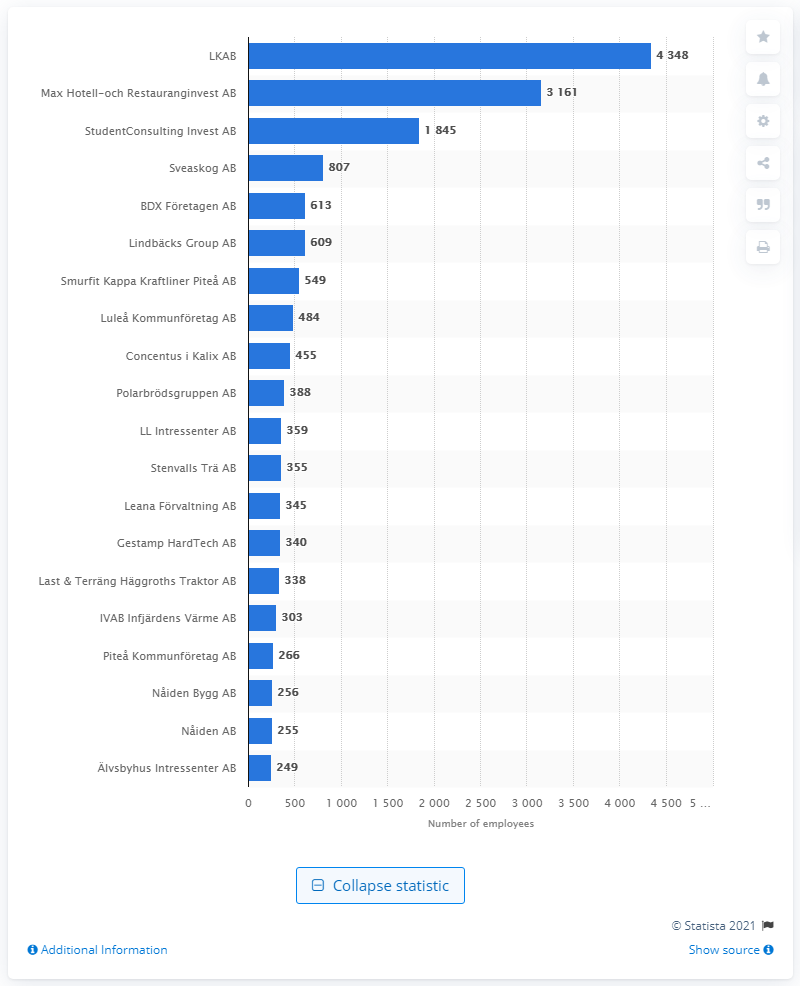Give some essential details in this illustration. As of February 2021, the largest company in Norrbotten county was LKAB. 